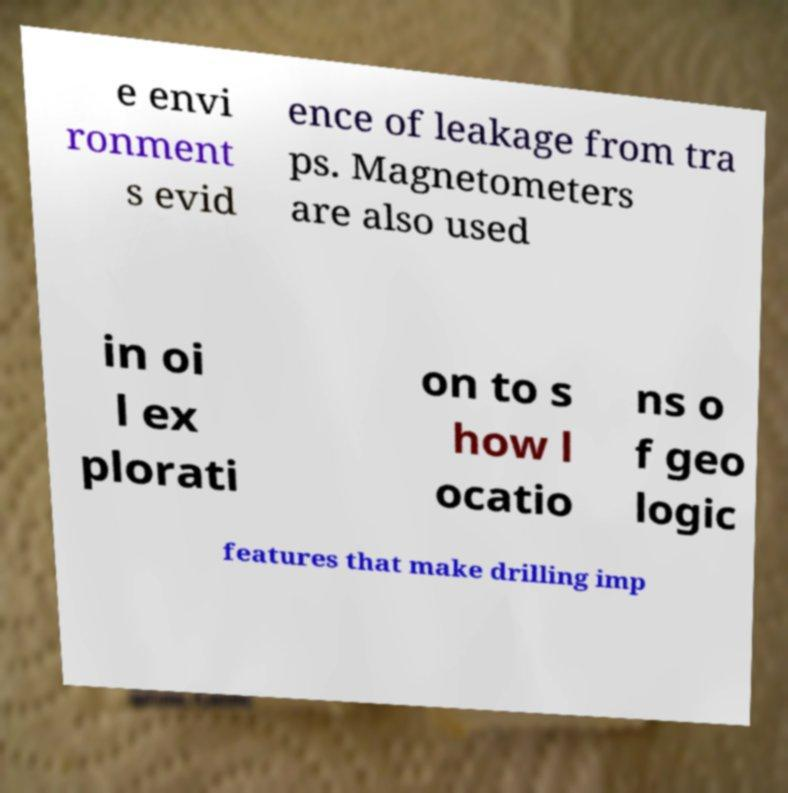What messages or text are displayed in this image? I need them in a readable, typed format. e envi ronment s evid ence of leakage from tra ps. Magnetometers are also used in oi l ex plorati on to s how l ocatio ns o f geo logic features that make drilling imp 